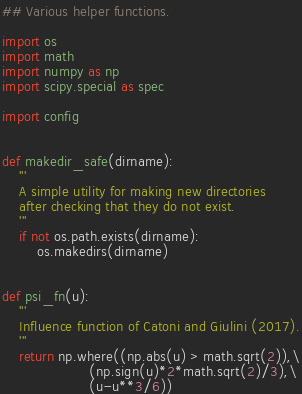<code> <loc_0><loc_0><loc_500><loc_500><_Python_>## Various helper functions.

import os
import math
import numpy as np
import scipy.special as spec

import config


def makedir_safe(dirname):
    '''
    A simple utility for making new directories
    after checking that they do not exist.
    '''
    if not os.path.exists(dirname):
        os.makedirs(dirname)
        

def psi_fn(u):
    '''
    Influence function of Catoni and Giulini (2017).
    '''
    return np.where((np.abs(u) > math.sqrt(2)),\
                    (np.sign(u)*2*math.sqrt(2)/3),\
                    (u-u**3/6))


</code> 